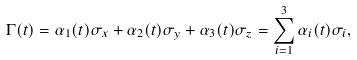<formula> <loc_0><loc_0><loc_500><loc_500>\Gamma ( t ) = \alpha _ { 1 } ( t ) \sigma _ { x } + \alpha _ { 2 } ( t ) \sigma _ { y } + \alpha _ { 3 } ( t ) \sigma _ { z } = \sum _ { i = 1 } ^ { 3 } \alpha _ { i } ( t ) \sigma _ { i } ,</formula> 